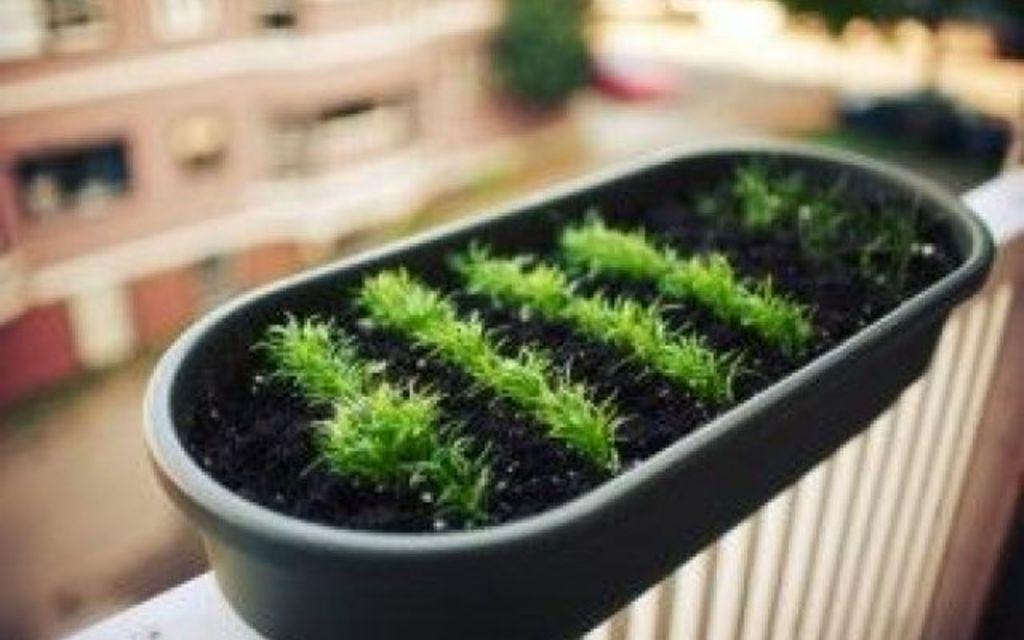What can be seen in the image that resembles a barrier or divider? There is a wall in the image. What object is present in the image that has a black color? There is a black color tray in the image. What type of vegetation is grown in the tray? Grass is grown in the tray. Can you describe the background of the image? There is another wall behind the tray, but it is not clearly visible. How many chairs are placed around the tray in the image? There are no chairs present in the image. What type of curve can be seen in the image? There is no curve visible in the image. 